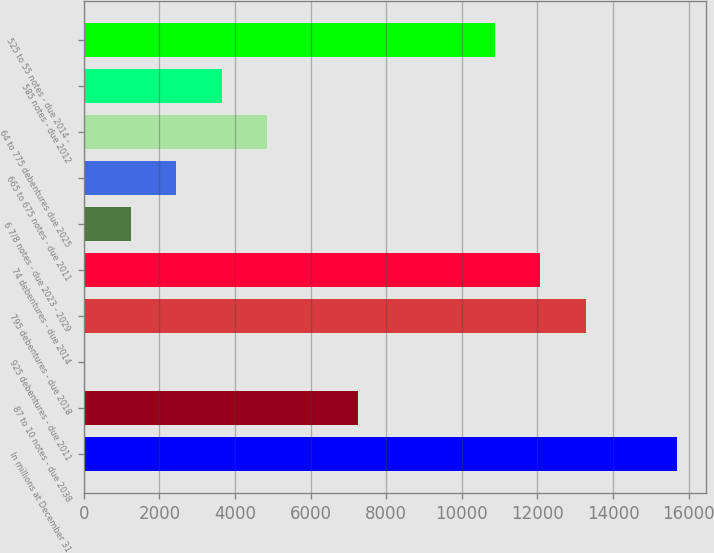Convert chart. <chart><loc_0><loc_0><loc_500><loc_500><bar_chart><fcel>In millions at December 31<fcel>87 to 10 notes - due 2038<fcel>925 debentures - due 2011<fcel>795 debentures - due 2018<fcel>74 debentures - due 2014<fcel>6 7/8 notes - due 2023 - 2029<fcel>665 to 675 notes - due 2011<fcel>64 to 775 debentures due 2025<fcel>585 notes - due 2012<fcel>525 to 55 notes - due 2014 -<nl><fcel>15683<fcel>7262<fcel>44<fcel>13277<fcel>12074<fcel>1247<fcel>2450<fcel>4856<fcel>3653<fcel>10871<nl></chart> 